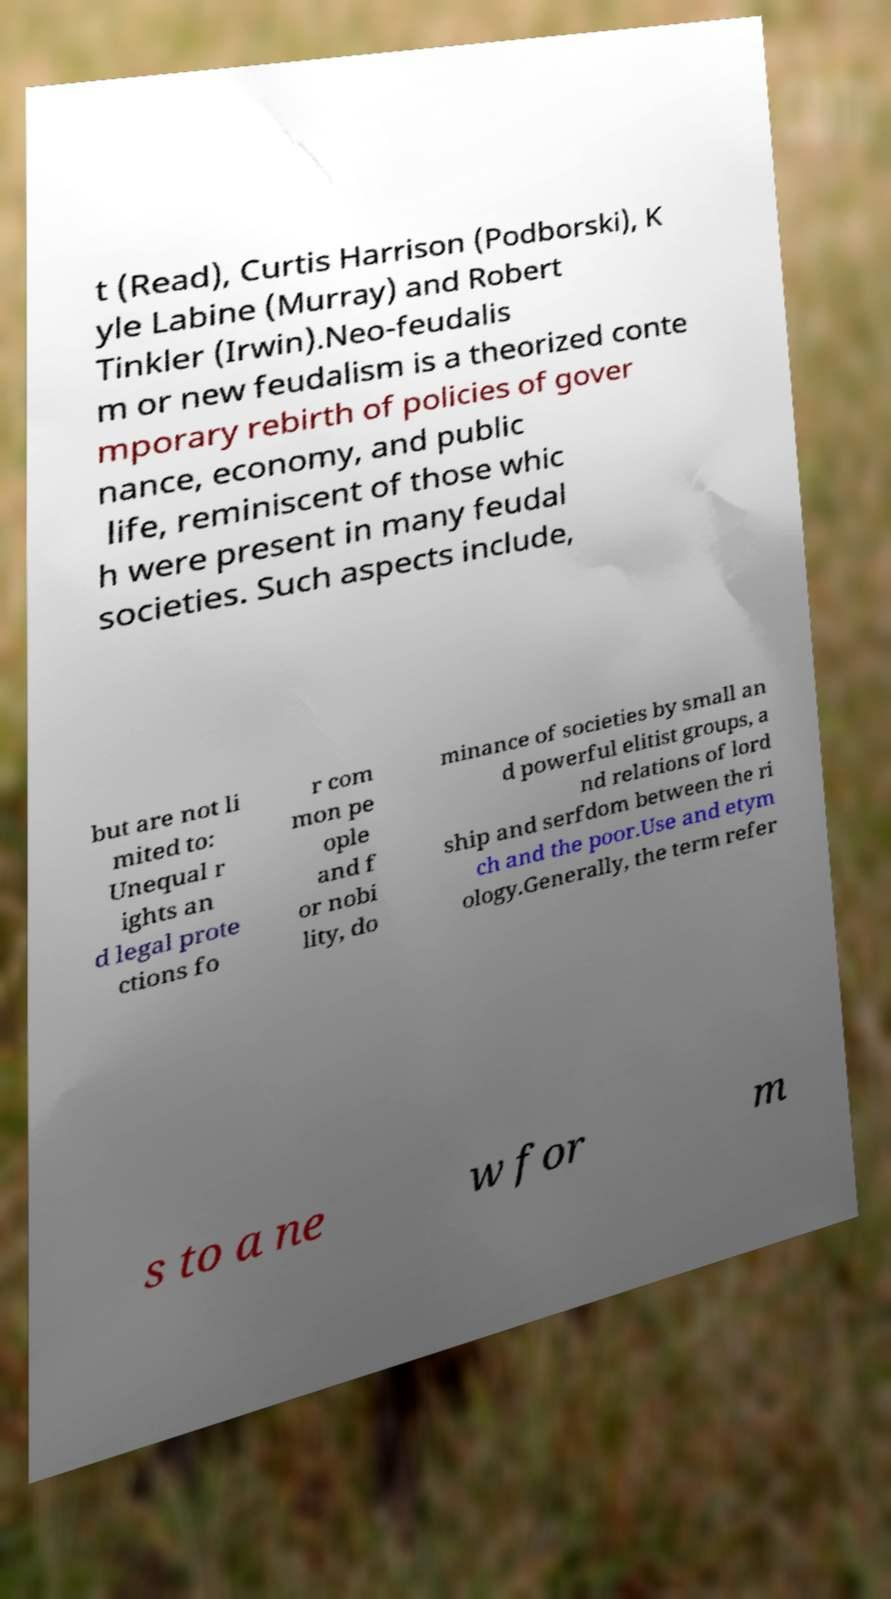For documentation purposes, I need the text within this image transcribed. Could you provide that? t (Read), Curtis Harrison (Podborski), K yle Labine (Murray) and Robert Tinkler (Irwin).Neo-feudalis m or new feudalism is a theorized conte mporary rebirth of policies of gover nance, economy, and public life, reminiscent of those whic h were present in many feudal societies. Such aspects include, but are not li mited to: Unequal r ights an d legal prote ctions fo r com mon pe ople and f or nobi lity, do minance of societies by small an d powerful elitist groups, a nd relations of lord ship and serfdom between the ri ch and the poor.Use and etym ology.Generally, the term refer s to a ne w for m 